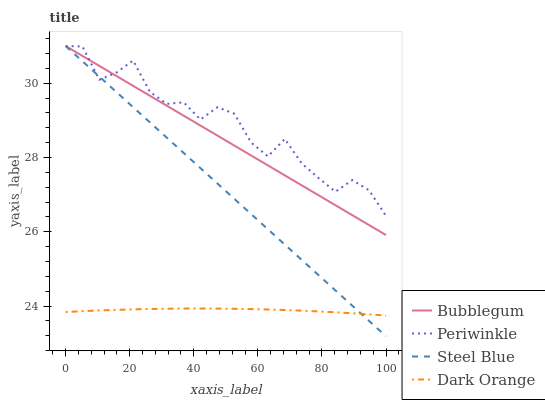Does Steel Blue have the minimum area under the curve?
Answer yes or no. No. Does Steel Blue have the maximum area under the curve?
Answer yes or no. No. Is Steel Blue the smoothest?
Answer yes or no. No. Is Steel Blue the roughest?
Answer yes or no. No. Does Periwinkle have the lowest value?
Answer yes or no. No. Is Dark Orange less than Bubblegum?
Answer yes or no. Yes. Is Bubblegum greater than Dark Orange?
Answer yes or no. Yes. Does Dark Orange intersect Bubblegum?
Answer yes or no. No. 